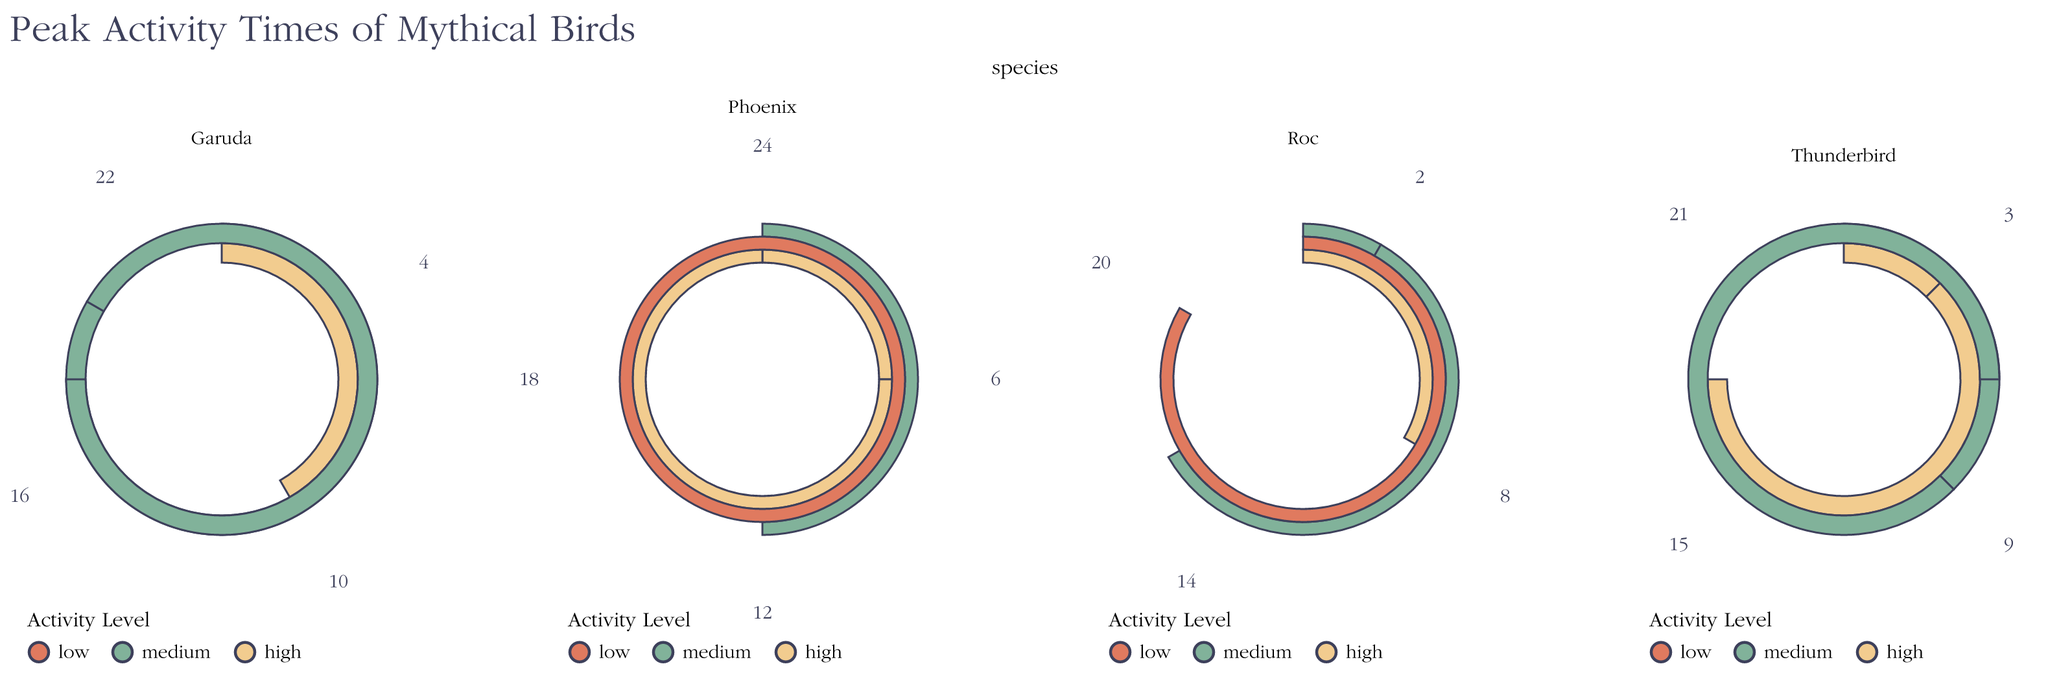What's the title of the chart? The title of the chart is displayed prominently at the top. It reads "Peak Activity Times of Mythical Birds."
Answer: Peak Activity Times of Mythical Birds Which species shows high activity at 6 am? By examining the plot, we see that the Phoenix has high activity at 6 am.
Answer: Phoenix At what time does the Roc show its highest activity level? The Roc's highest activity level (high) is indicated at 8 am.
Answer: 8 am Which species has the most high activity peaks? To find this, count the high activity peaks for each species. Phoenix has high activity twice (6 am, 18 pm), Thunderbird twice (3 am, 15 pm), Garuda once (10 am), and Roc once (8 am). The Phoenix and Thunderbird each have the most with two high activity peaks.
Answer: Phoenix, Thunderbird What is the average peak hour for Garuda? Garuda's peak hours are at 4, 10, 16, and 22. Adding them: 4 + 10 + 16 + 22 = 52. Dividing by 4: 52 / 4 = 13. Garuda's average peak hour is 13 (1 pm).
Answer: 1 pm During which hour does the Phoenix have its lowest activity level? The Phoenix has its lowest activity level (low) at 24 (midnight).
Answer: midnight Comparing Thunderbird and Garuda, which species has the highest activity level more frequently? Thunderbird shows high activity at 3 am and 15 pm, while Garuda shows high activity only once at 10 am. Therefore, Thunderbird has high activity more frequently.
Answer: Thunderbird Which species has similar activity levels throughout the day? Garuda has medium activity at 4, 16, and 22, maintaining a relatively consistent activity level throughout the day.
Answer: Garuda Considering all species, how many have a low activity level at any time? By inspecting the plots, only Phoenix and Roc exhibit a low activity level, at 24 (midnight) and 20 (8 pm) respectively.
Answer: Two species 